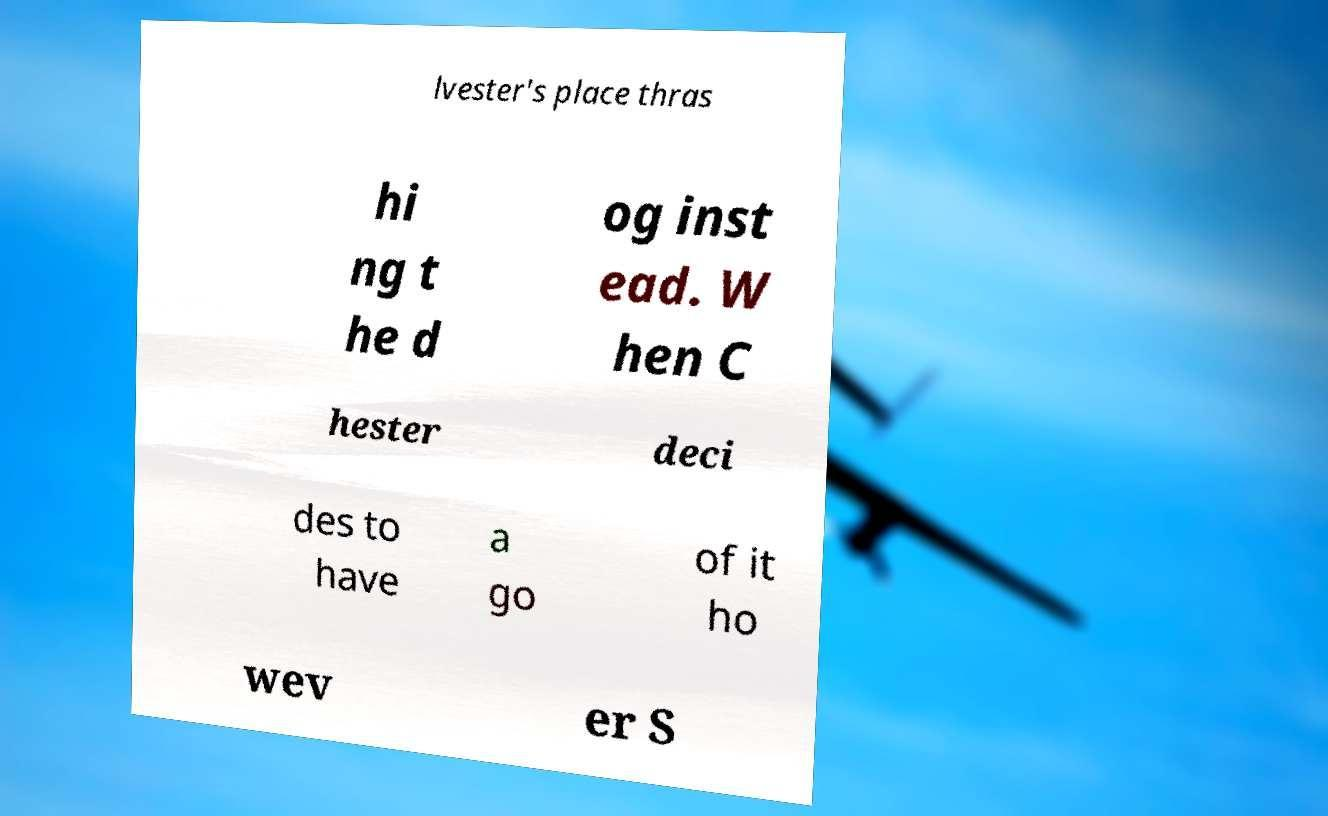I need the written content from this picture converted into text. Can you do that? lvester's place thras hi ng t he d og inst ead. W hen C hester deci des to have a go of it ho wev er S 